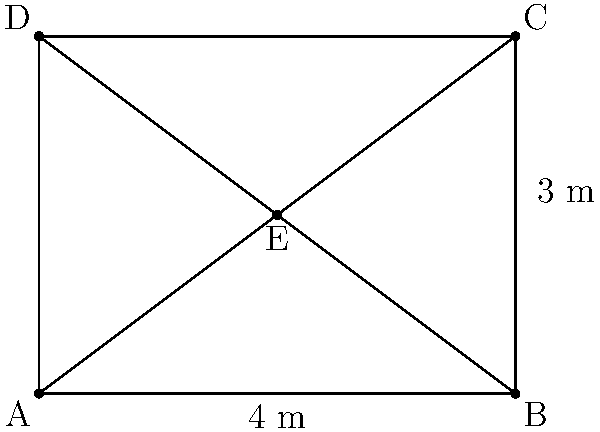A satellite's solar panel array is designed in the shape of a rectangle with dimensions 4 m by 3 m. To increase its efficiency, engineers are considering adding diagonal supports that intersect at the center point E. If the goal is to maximize the area of the largest triangular section created by these supports, what should be the area of this largest triangle? Let's approach this step-by-step:

1) The rectangle ABCD has dimensions 4 m by 3 m.

2) Point E is at the center of the rectangle, so its coordinates are (2, 1.5).

3) The diagonal supports create four triangles: AEB, BEC, CED, and DEA.

4) Due to the symmetry of the rectangle and the central point E, these triangles are congruent in pairs: AEB ≅ CED and BEC ≅ DEA.

5) To find the largest triangle, we need to compare the areas of AEB and BEC.

6) For triangle AEB:
   Base (AB) = 4 m
   Height = 1.5 m (half the rectangle's height)
   Area of AEB = $\frac{1}{2} \times 4 \times 1.5 = 3$ sq m

7) For triangle BEC:
   Base (BC) = 3 m
   Height = 2 m (half the rectangle's width)
   Area of BEC = $\frac{1}{2} \times 3 \times 2 = 3$ sq m

8) Both triangles have the same area of 3 sq m.

Therefore, the largest triangular section has an area of 3 square meters.
Answer: 3 square meters 